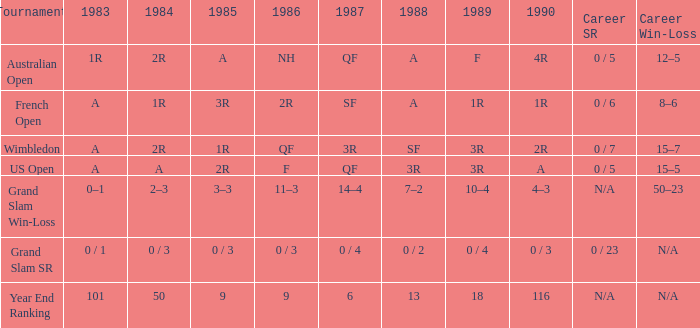What are the 1987 findings when the findings of 1989 are 3r, and the 1986 findings are f? QF. 